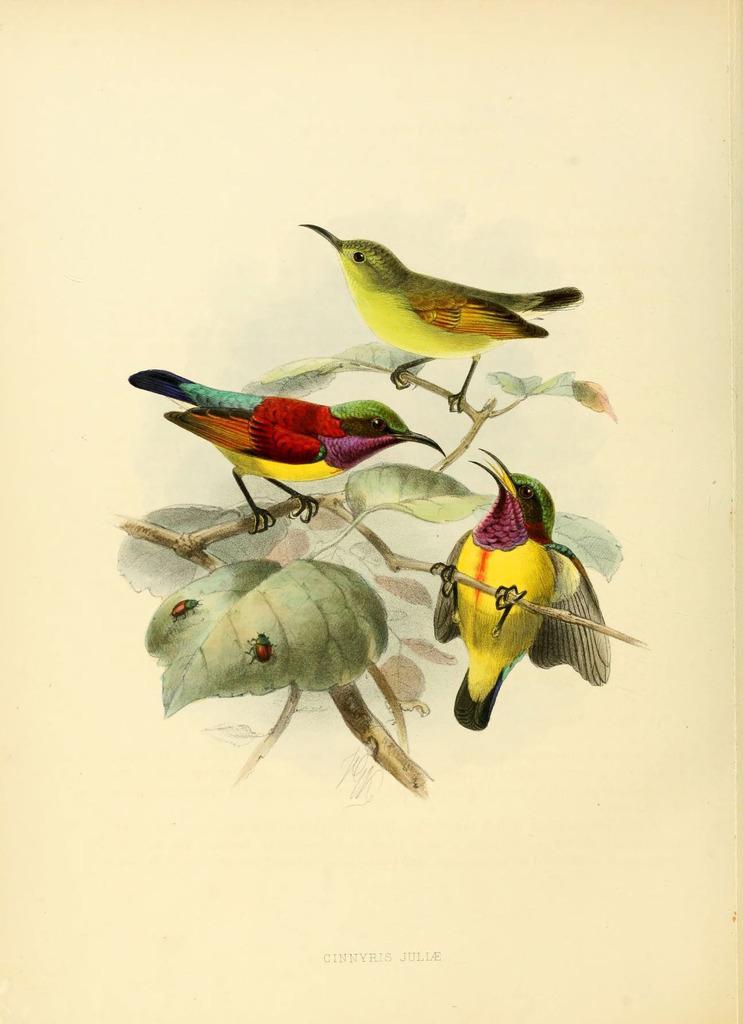Can you describe this image briefly? This picture is a painting. In this image there is a painting of a birds on the tree and there are two insects on the leaf. At the bottom there is a text. At the back there is a cream color background. 